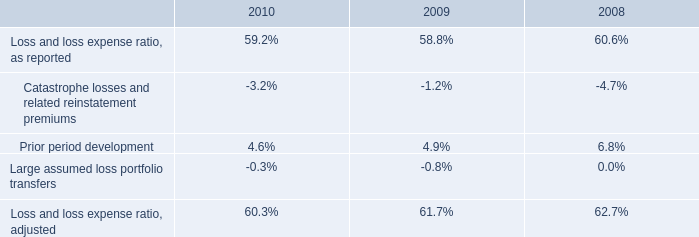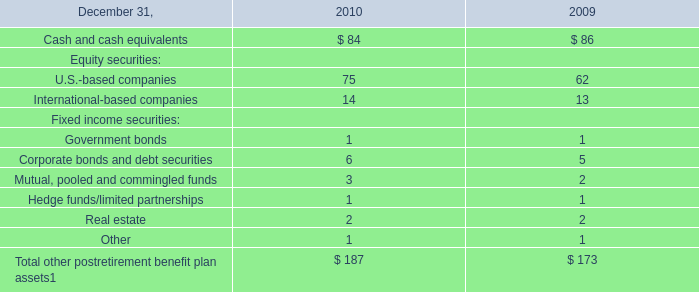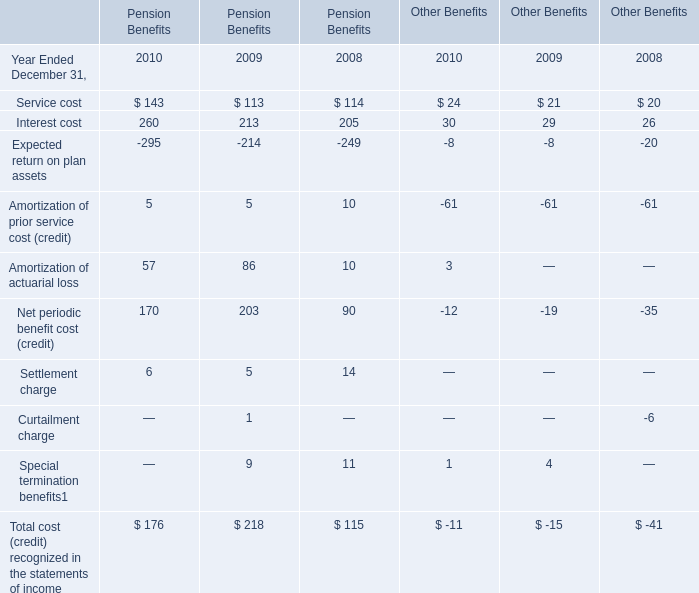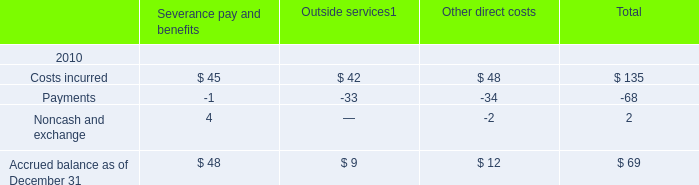what was the average catastrophe losses from 2008 to 2010 in millions 
Computations: ((567 + (366 + 137)) / 3)
Answer: 356.66667. 